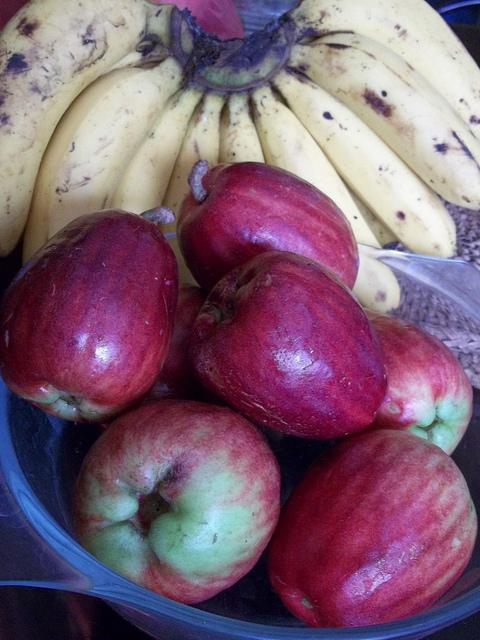Which country grows most bananas? india 